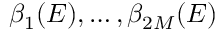<formula> <loc_0><loc_0><loc_500><loc_500>\beta _ { 1 } ( E ) , \dots , \beta _ { 2 M } ( E )</formula> 